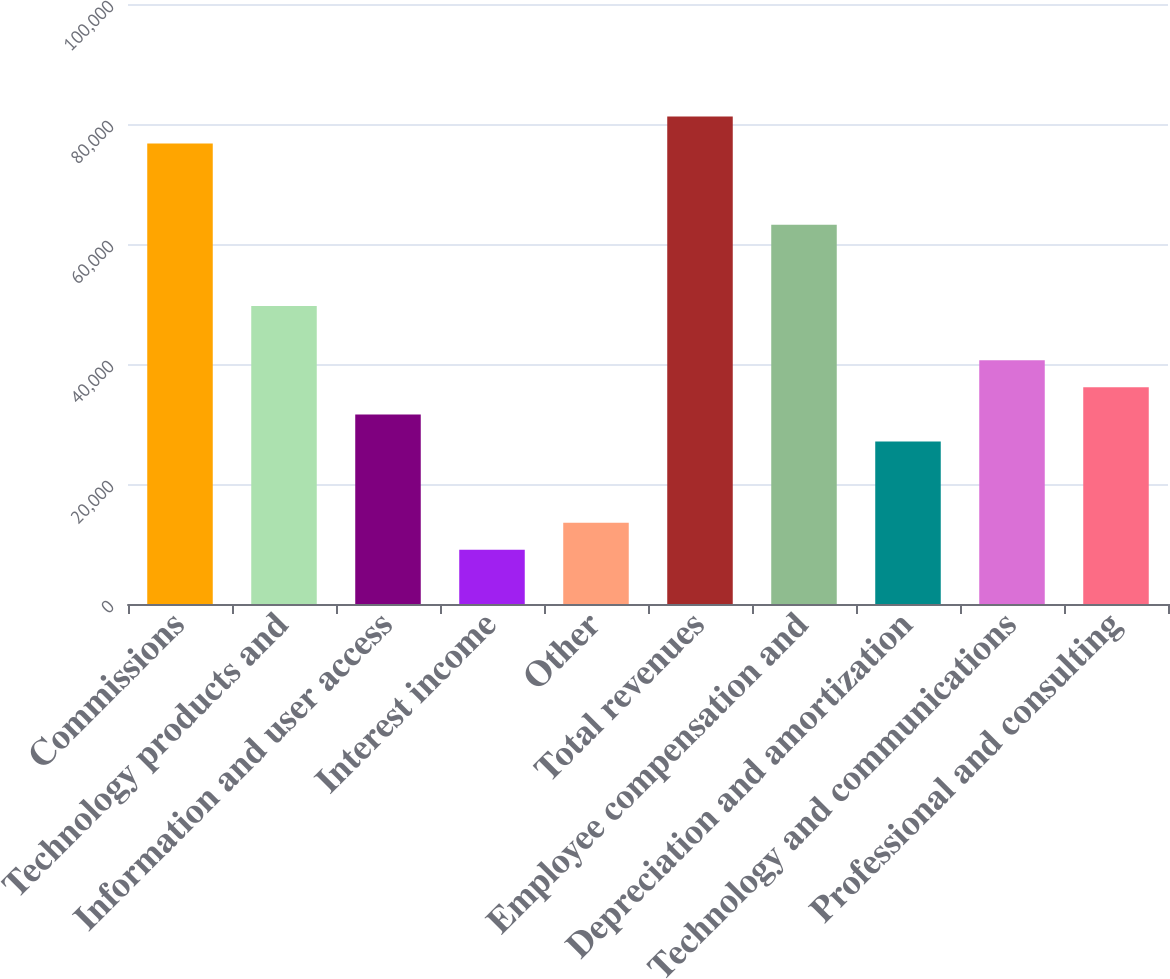Convert chart. <chart><loc_0><loc_0><loc_500><loc_500><bar_chart><fcel>Commissions<fcel>Technology products and<fcel>Information and user access<fcel>Interest income<fcel>Other<fcel>Total revenues<fcel>Employee compensation and<fcel>Depreciation and amortization<fcel>Technology and communications<fcel>Professional and consulting<nl><fcel>76729.3<fcel>49648.5<fcel>31594.6<fcel>9027.23<fcel>13540.7<fcel>81242.8<fcel>63188.9<fcel>27081.1<fcel>40621.5<fcel>36108.1<nl></chart> 